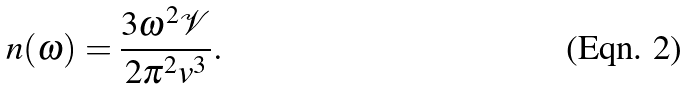<formula> <loc_0><loc_0><loc_500><loc_500>n ( \omega ) = \frac { 3 \omega ^ { 2 } \mathcal { V } } { 2 \pi ^ { 2 } v ^ { 3 } } .</formula> 